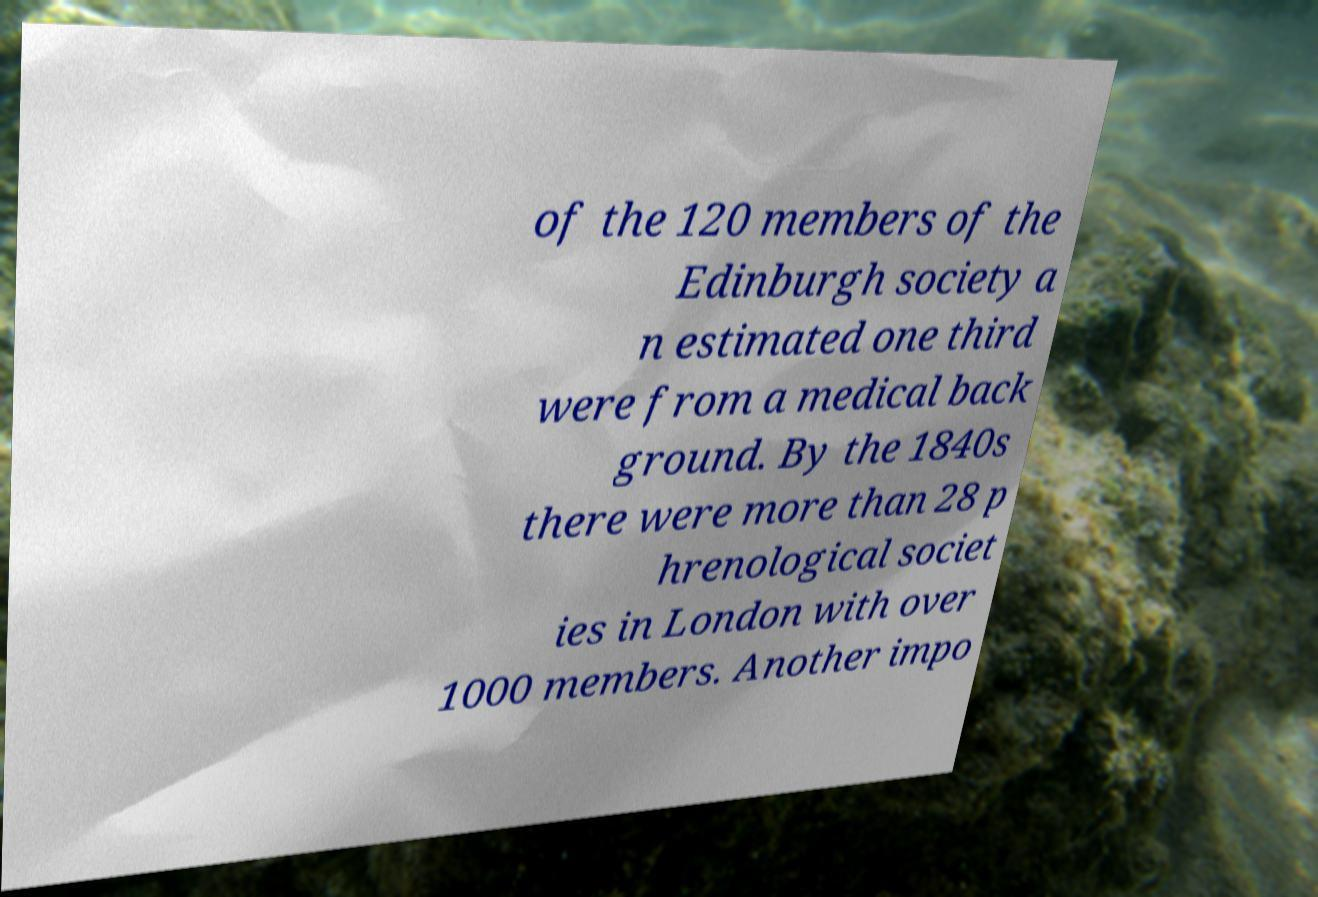Please identify and transcribe the text found in this image. of the 120 members of the Edinburgh society a n estimated one third were from a medical back ground. By the 1840s there were more than 28 p hrenological societ ies in London with over 1000 members. Another impo 